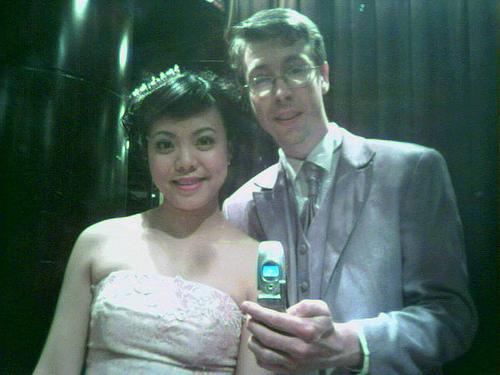What is the man using the phone to do? take picture 